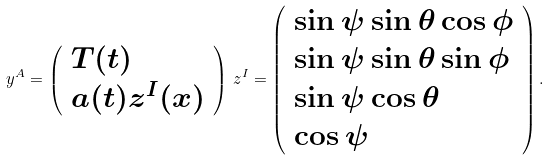<formula> <loc_0><loc_0><loc_500><loc_500>y ^ { A } = \left ( \begin{array} { l } T ( t ) \\ a ( t ) z ^ { I } ( x ) \end{array} \right ) \, z ^ { I } = \left ( \begin{array} { l } \sin \psi \sin \theta \cos \phi \\ \sin \psi \sin \theta \sin \phi \\ \sin \psi \cos \theta \\ \cos \psi \end{array} \right ) .</formula> 